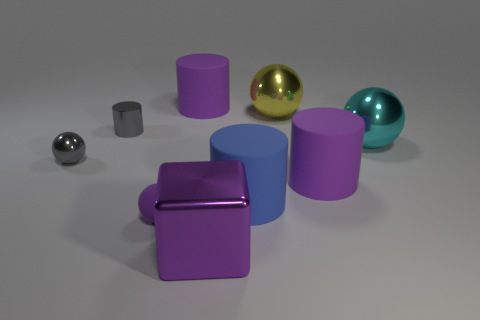Subtract all small gray cylinders. How many cylinders are left? 3 Add 5 big red rubber cylinders. How many big red rubber cylinders exist? 5 Add 1 small purple shiny spheres. How many objects exist? 10 Subtract all blue cylinders. How many cylinders are left? 3 Subtract 1 blue cylinders. How many objects are left? 8 Subtract all cubes. How many objects are left? 8 Subtract 4 spheres. How many spheres are left? 0 Subtract all gray spheres. Subtract all cyan cylinders. How many spheres are left? 3 Subtract all gray blocks. How many purple spheres are left? 1 Subtract all big objects. Subtract all small things. How many objects are left? 0 